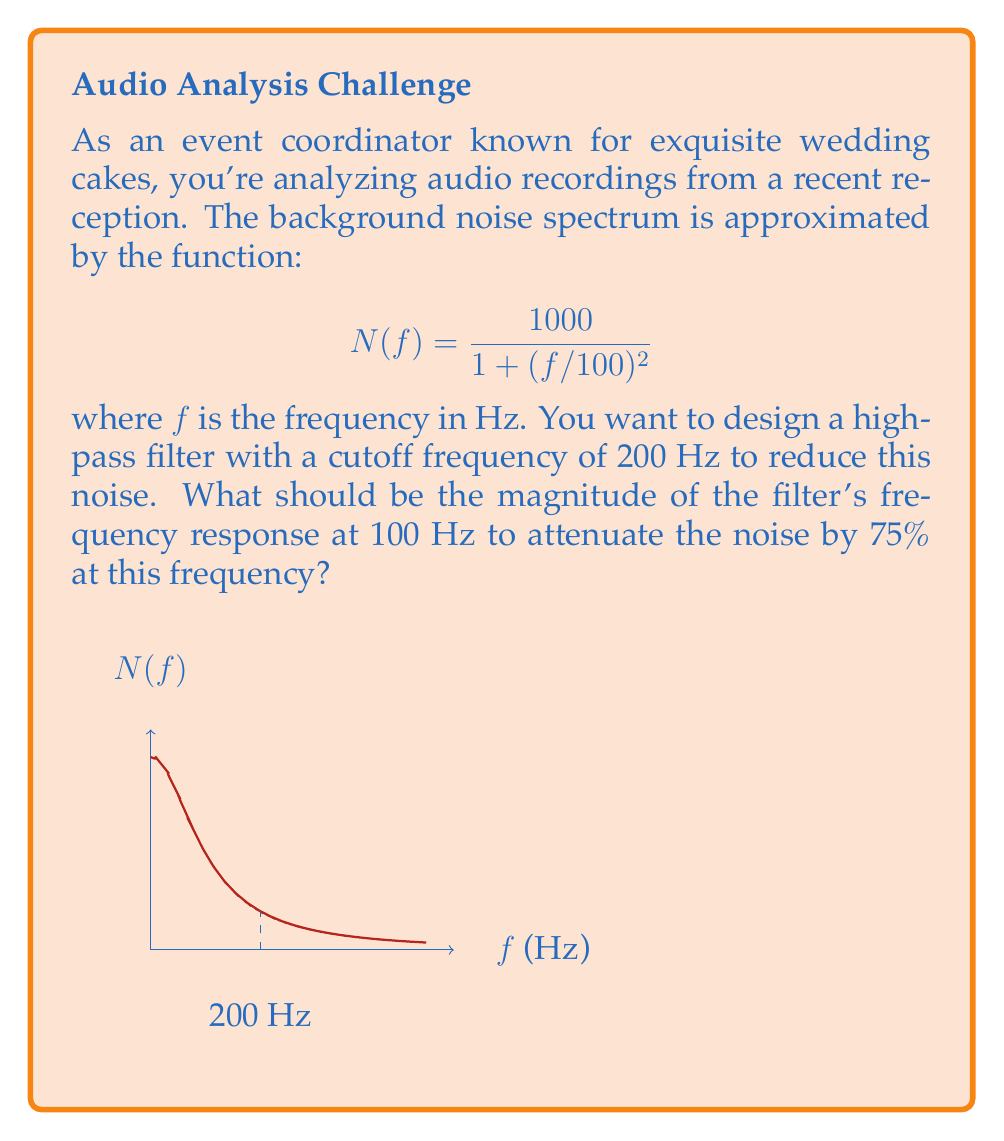Provide a solution to this math problem. Let's approach this step-by-step:

1) The high-pass filter's frequency response can be represented as $H(f)$. We want to find $|H(100)|$, the magnitude at 100 Hz.

2) At the cutoff frequency (200 Hz), the filter's response is typically -3 dB, or about 0.707 in magnitude. At frequencies below this, the attenuation increases.

3) We need to reduce the noise at 100 Hz by 75%. This means we want to pass only 25% of the signal at this frequency.

4) Let's express this mathematically:

   $$|H(100)| \cdot N(100) = 0.25 \cdot N(100)$$

5) Simplifying:

   $$|H(100)| = 0.25$$

6) This means the magnitude of the filter's frequency response at 100 Hz should be 0.25 or 25%.

7) We can verify:
   - Without the filter: $N(100) = \frac{1000}{1 + (100/100)^2} = 500$
   - With the filter: $0.25 \cdot 500 = 125$, which is indeed a 75% reduction.
Answer: $|H(100)| = 0.25$ 